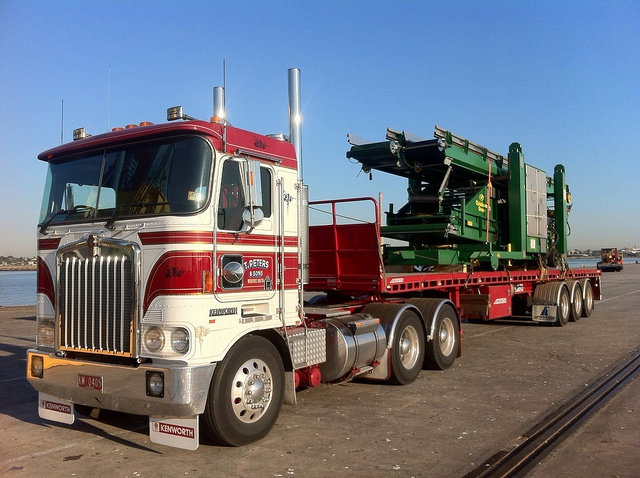Describe the objects in this image and their specific colors. I can see truck in gray, black, maroon, and darkgray tones and truck in gray, black, maroon, and brown tones in this image. 